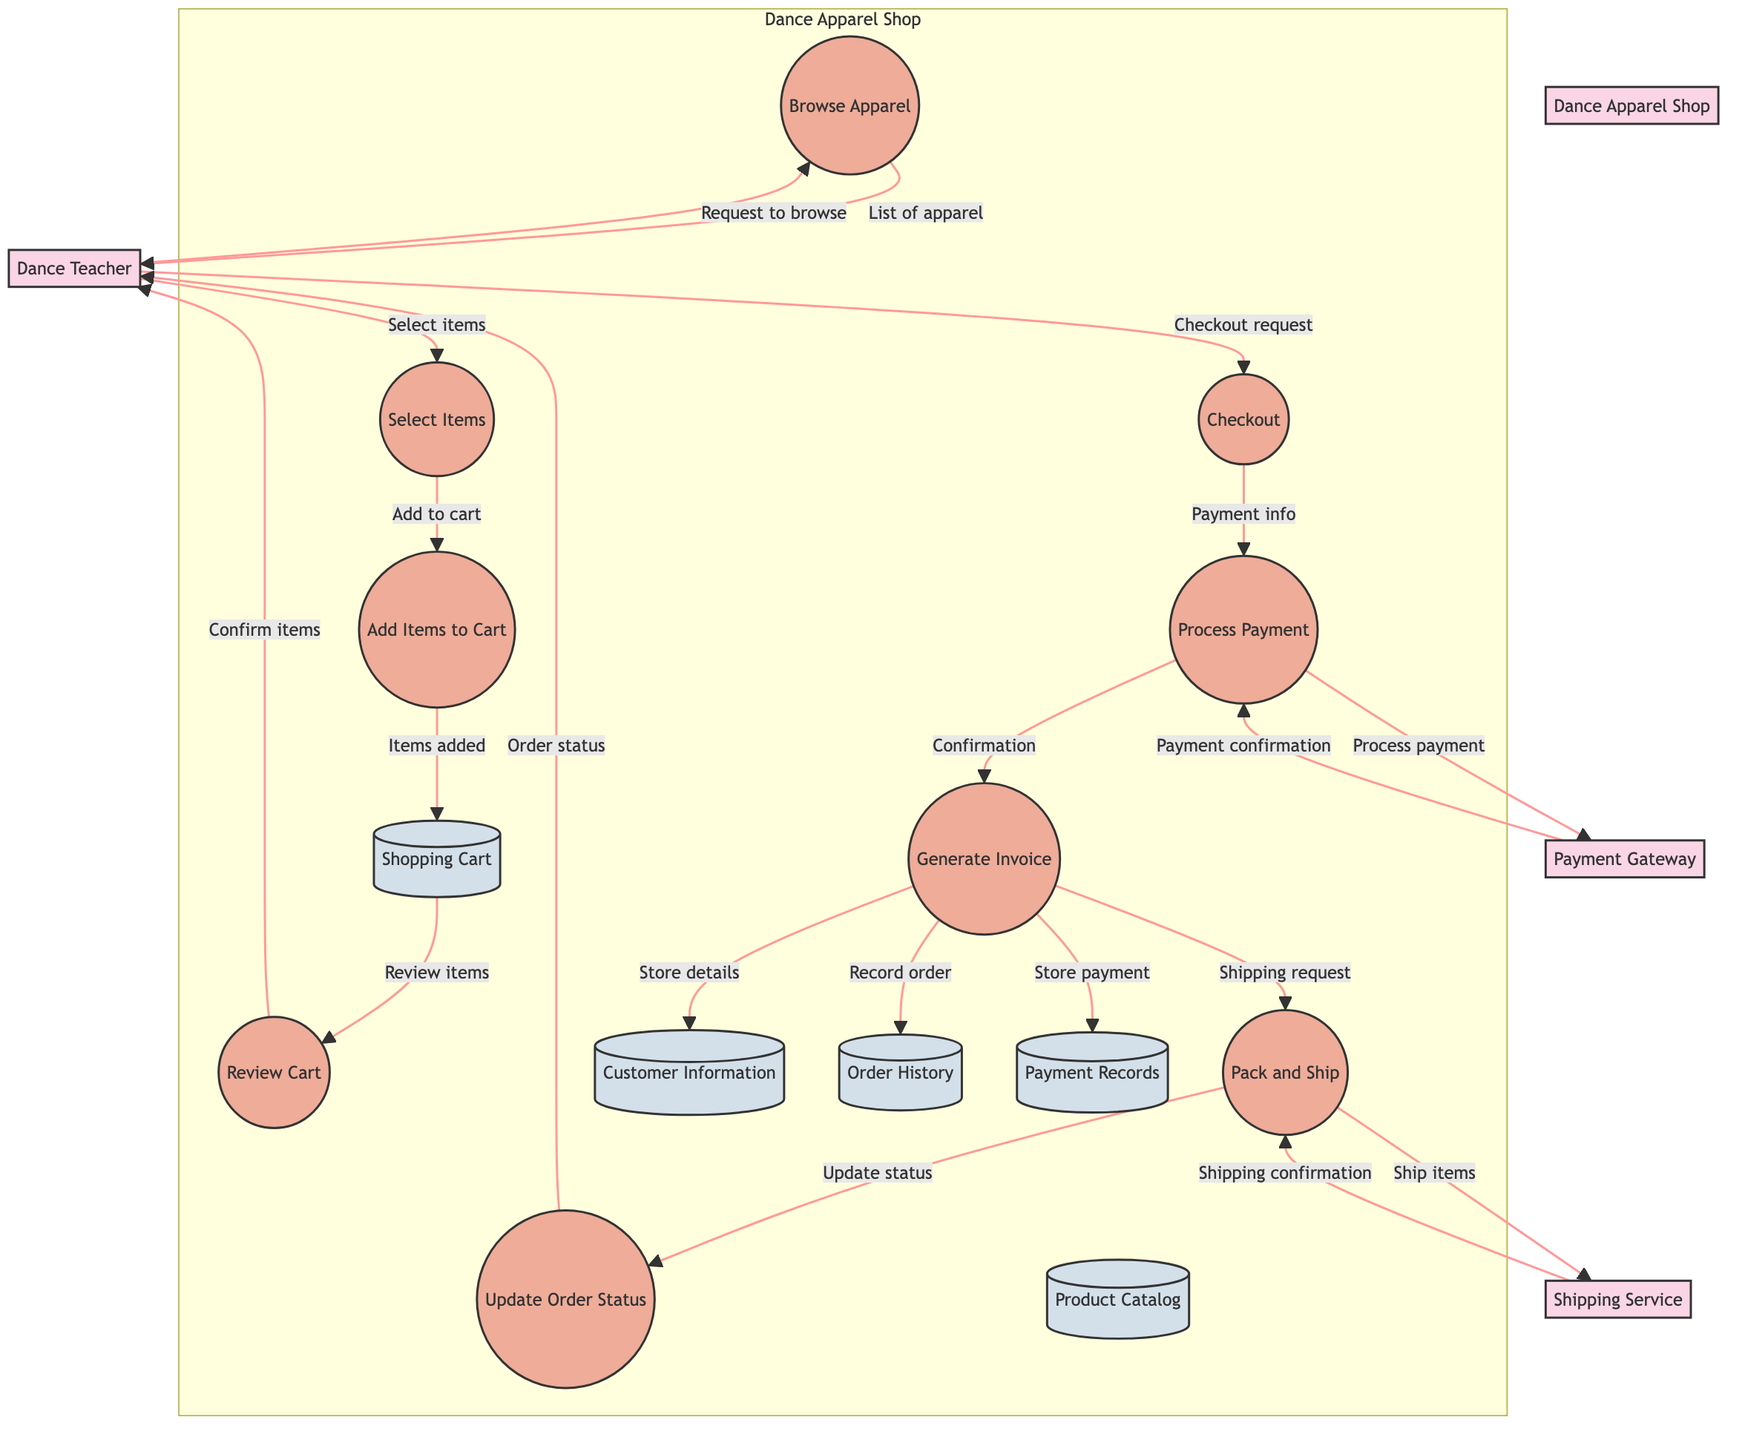What is the first process the Dance Teacher engages in? The first process in the diagram initiated by the Dance Teacher is "Browse Apparel," which is the starting point for exploring available items.
Answer: Browse Apparel How many external entities are represented in the diagram? The diagram includes four external entities: Dance Teacher, Dance Apparel Shop, Payment Gateway, and Shipping Service. Thus, the count of external entities is four.
Answer: Four Which process follows the "Review Cart" process? After the "Review Cart" process, the next step is "Checkout." This is confirmed by the direct flow from "Review Cart" to "Checkout" indicated in the diagram.
Answer: Checkout What does the Payment Gateway send after processing payment? After processing payment, the Payment Gateway sends back "Payment confirmation" to the Dance Apparel Shop, as shown in the flow between these two nodes.
Answer: Payment confirmation How many data stores are listed in the diagram? There are five data stores: Product Catalog, Shopping Cart, Customer Information, Order History, and Payment Records. This can be counted directly in the diagram.
Answer: Five What initiates the "Pack and Ship" process? The "Pack and Ship" process is initiated by a shipping request that includes order details sent from the Dance Apparel Shop to the Shipping Service. This flow indicates the start of the packing and shipping activities based on that request.
Answer: Shipping request What is the relationship between the "Checkout" process and "Process Payment"? The diagram shows that "Checkout" sends "Payment info" to "Process Payment," establishing a direct relationship where checkout is dependent on processing the payment to finalize the order.
Answer: Payment info Which data store holds customer details like shipping addresses? The data store that holds customer details such as shipping addresses is labeled "Customer Information," as shown in the data stores section of the diagram.
Answer: Customer Information 